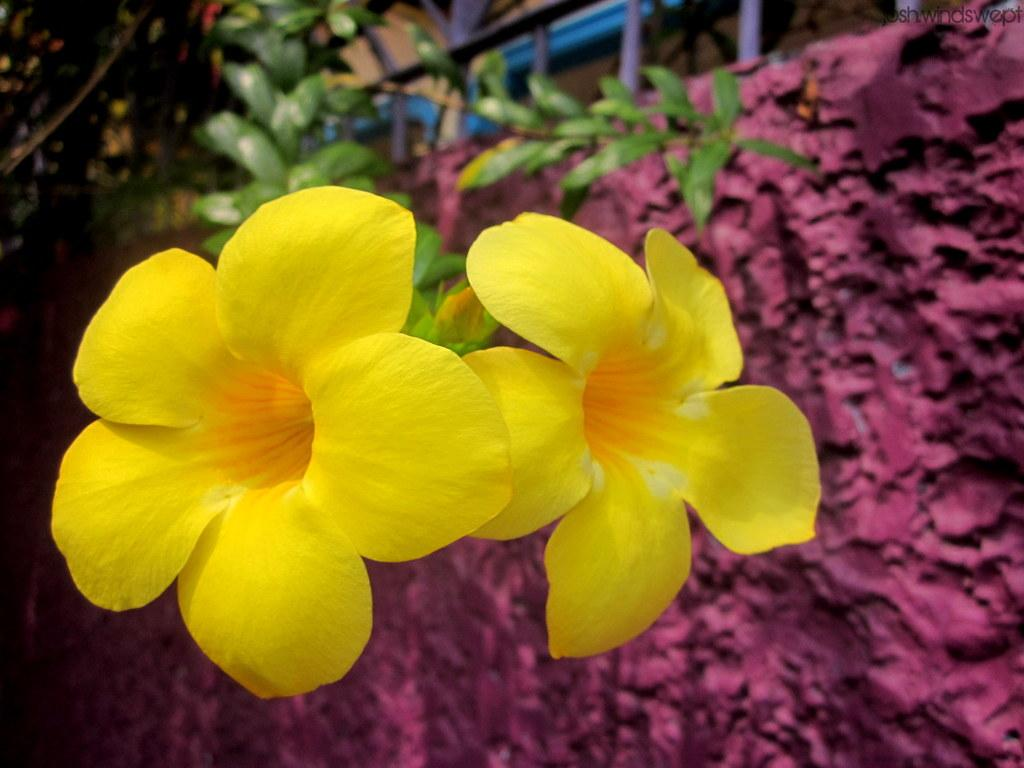How many flowers are in the image? There are two flowers in the image. What color are the flowers? The flowers are yellow. What can be seen on the right side of the image? There is a wall on the right side of the image. What color is the wall? The wall is pink. What else can be seen in the background of the image? There is a plant in the background of the image. How does the snake use the fuel in the image? There is no snake or fuel present in the image. What type of balance is required for the flowers to grow in the image? The image does not show the flowers growing, nor does it provide information about the balance required for their growth. 